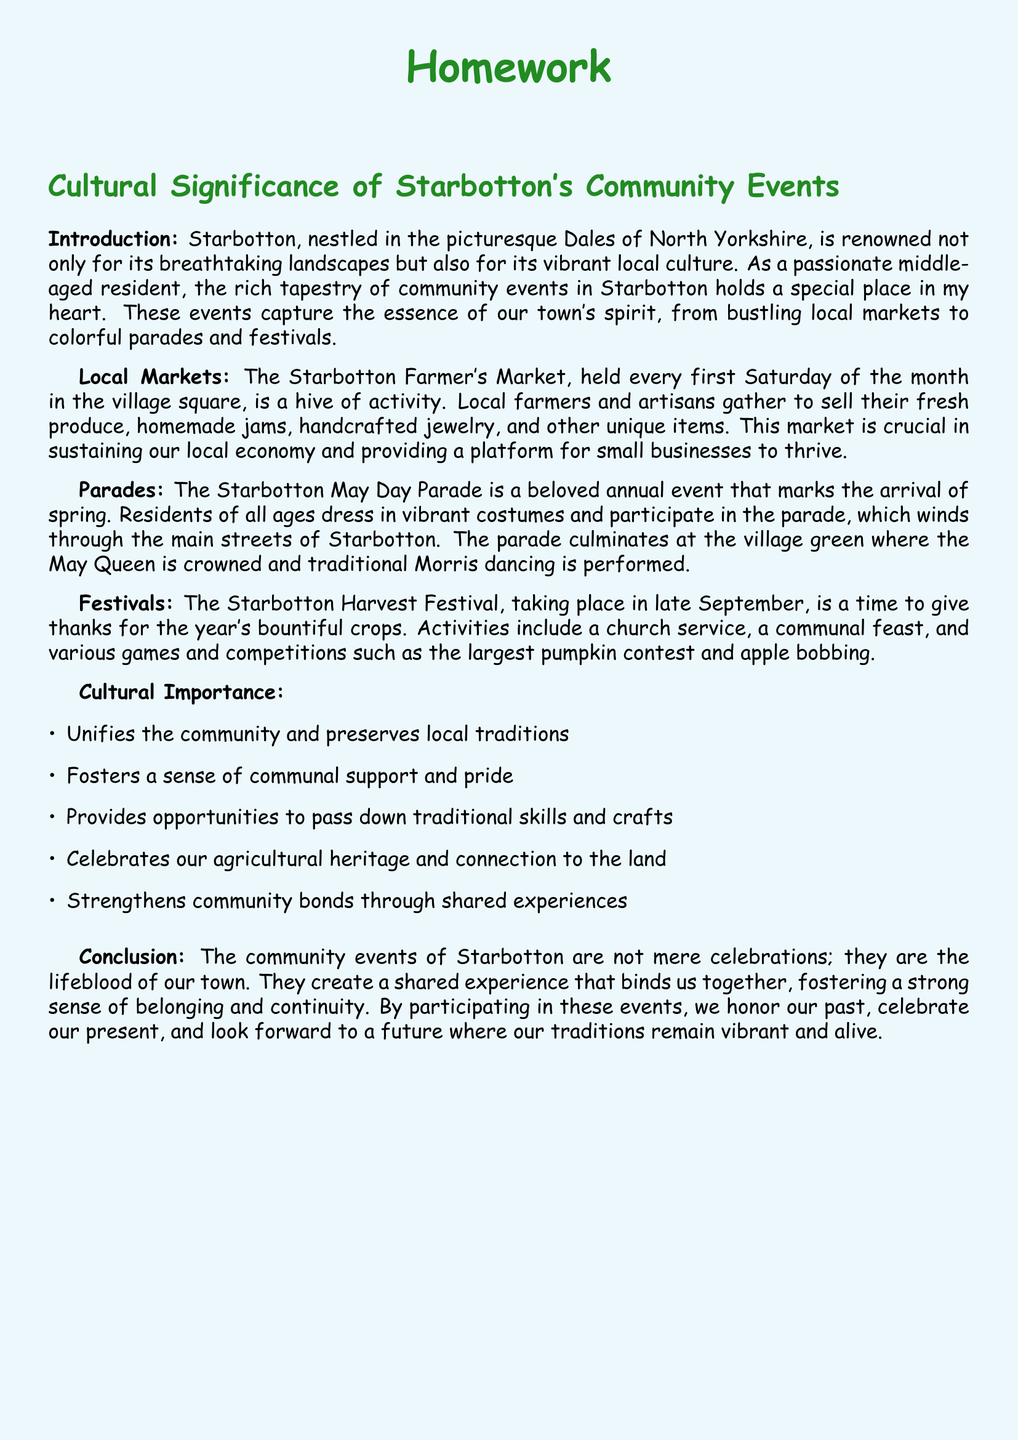What is the first Saturday of the month event? The first Saturday of the month features the Starbotton Farmer's Market, where local farmers and artisans gather to sell their goods.
Answer: Starbotton Farmer's Market What marks the arrival of spring in Starbotton? The Starbotton May Day Parade is the event that marks the arrival of spring, celebrated annually with vibrant costumes and a procession.
Answer: May Day Parade What is a featured activity at the Harvest Festival? The Harvest Festival includes a variety of games and competitions, one of which is the largest pumpkin contest.
Answer: Largest pumpkin contest What color is associated with the title of the homework? The title of the homework is styled in a specific color, green, indicating its significance and cultural connection.
Answer: Dalegreen What aspect of community events strengthens local bonds? Community events foster shared experiences, which help to strengthen community bonds among residents.
Answer: Shared experiences 